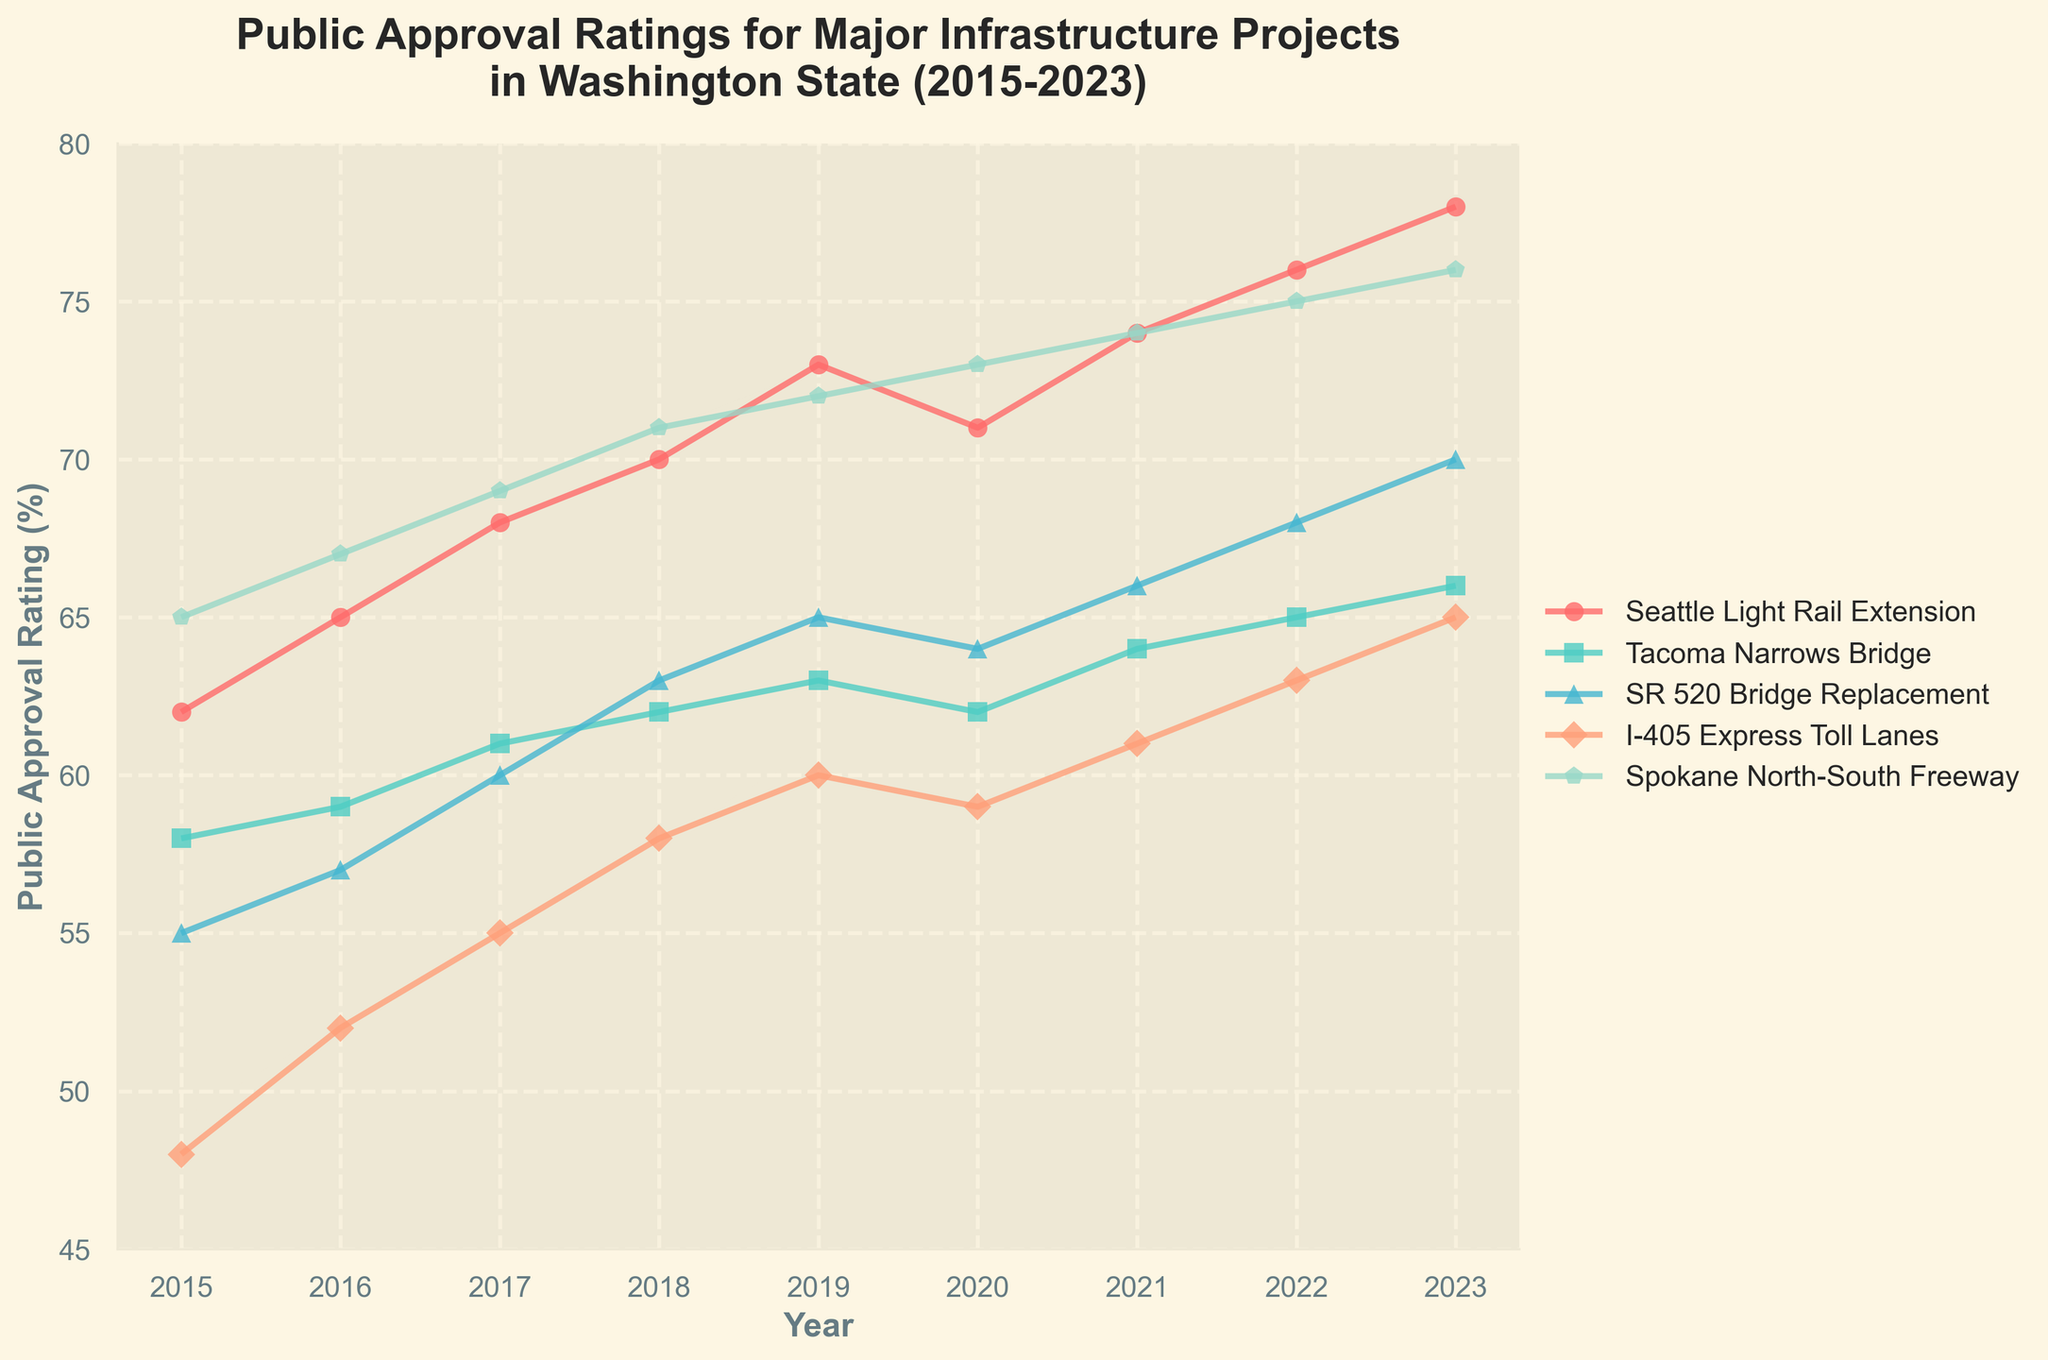What is the overall trend in the public approval rating for the Seattle Light Rail Extension from 2015 to 2023? The plot shows a clear upward trend in the public approval rating for the Seattle Light Rail Extension from 2015 to 2023, starting at 62% in 2015 and reaching 78% in 2023, indicating increased public favorability over time.
Answer: Upward trend Which project had the highest public approval rating in 2023? By reviewing the data points for 2023 in the figure, we can see that the Spokane North-South Freeway had the highest public approval rating at 76%.
Answer: Spokane North-South Freeway Among the projects, which one has the smallest change in public approval rating from 2015 to 2023? To determine the smallest change, we subtract the approval ratings in 2015 from those in 2023 for each project. The Tacoma Narrows Bridge shows a change from 58% in 2015 to 66% in 2023, which is an 8% increase, the smallest change among the projects listed.
Answer: Tacoma Narrows Bridge What is the difference in public approval ratings between the I-405 Express Toll Lanes and SR 520 Bridge Replacement in 2021? For 2021, the I-405 Express Toll Lanes had an approval rating of 61%, and the SR 520 Bridge Replacement had 66%. The difference is 66% - 61% = 5%.
Answer: 5% Which project showed the greatest increase in public approval ratings from 2020 to 2023? To find this, we calculate the change for each project from 2020 to 2023. The Spokane North-South Freeway increased from 73% to 76% (+3%), I-405 Express Toll Lanes from 59% to 65% (+6%), SR 520 Bridge Replacement from 64% to 70% (+6%), Tacoma Narrows Bridge from 62% to 66% (+4%) and Seattle Light Rail Extension from 71% to 78% (+7%). Seattle Light Rail Extension shows the greatest increase of 7%.
Answer: Seattle Light Rail Extension How does the public approval rating for Tacoma Narrows Bridge in 2018 compare to the I-405 Express Toll Lanes? In 2018, the Tacoma Narrows Bridge has a 62% approval rating, whereas the I-405 Express Toll Lanes has 58%. Therefore, the Tacoma Narrows Bridge has a 4% higher approval rating than the I-405 Express Toll Lanes.
Answer: 4% higher Which two projects have the closest public approval ratings in 2019? In 2019, the approval ratings are: Seattle Light Rail Extension (73%), Tacoma Narrows Bridge (63%), SR 520 Bridge Replacement (65%), I-405 Express Toll Lanes (60%), and Spokane North-South Freeway (72%). The SR 520 Bridge Replacement (65%) and Tacoma Narrows Bridge (63%) have the closest approval ratings with a difference of just 2%.
Answer: SR 520 Bridge Replacement and Tacoma Narrows Bridge Between SR 520 Bridge Replacement and I-405 Express Toll Lanes, which project had more years with increasing approval ratings from 2015 to 2023? Reviewing the plot for each year between 2015 and 2023: SR 520 Bridge Replacement increased in 6 years (2016, 2017, 2018, 2019, 2021, 2022, 2023) and I-405 Express Toll Lanes increased in 5 years (2016, 2017, 2018, 2019, 2021, 2023). The SR 520 Bridge Replacement had more years with increasing ratings.
Answer: SR 520 Bridge Replacement What is the combined approval rating of all projects in 2023? Adding the approval ratings of all projects in 2023: Seattle Light Rail Extension (78%) + Tacoma Narrows Bridge (66%) + SR 520 Bridge Replacement (70%) + I-405 Express Toll Lanes (65%) + Spokane North-South Freeway (76%) equals 355%.
Answer: 355% 